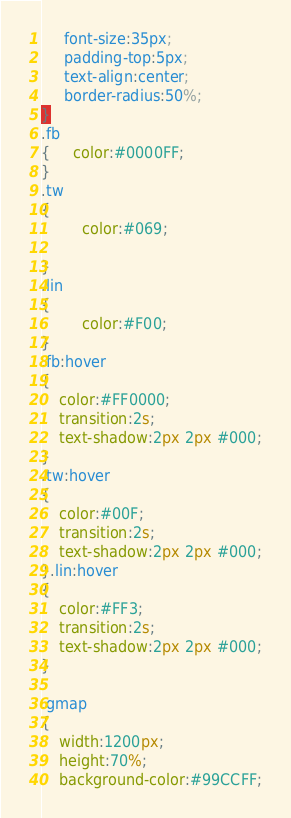<code> <loc_0><loc_0><loc_500><loc_500><_CSS_>	 font-size:35px;
	 padding-top:5px;
	 text-align:center;
	 border-radius:50%;
}
.fb
{	 color:#0000FF;
}
.tw
{
		 color:#069;

}
.lin
{
		 color:#F00;
}
.fb:hover
{
	color:#FF0000;
	transition:2s;
	text-shadow:2px 2px #000;
}
.tw:hover
{
	color:#00F;
	transition:2s;
	text-shadow:2px 2px #000;
}.lin:hover
{
	color:#FF3;
	transition:2s;
	text-shadow:2px 2px #000;
}

.gmap
{
	width:1200px;
	height:70%;
	background-color:#99CCFF;

</code> 